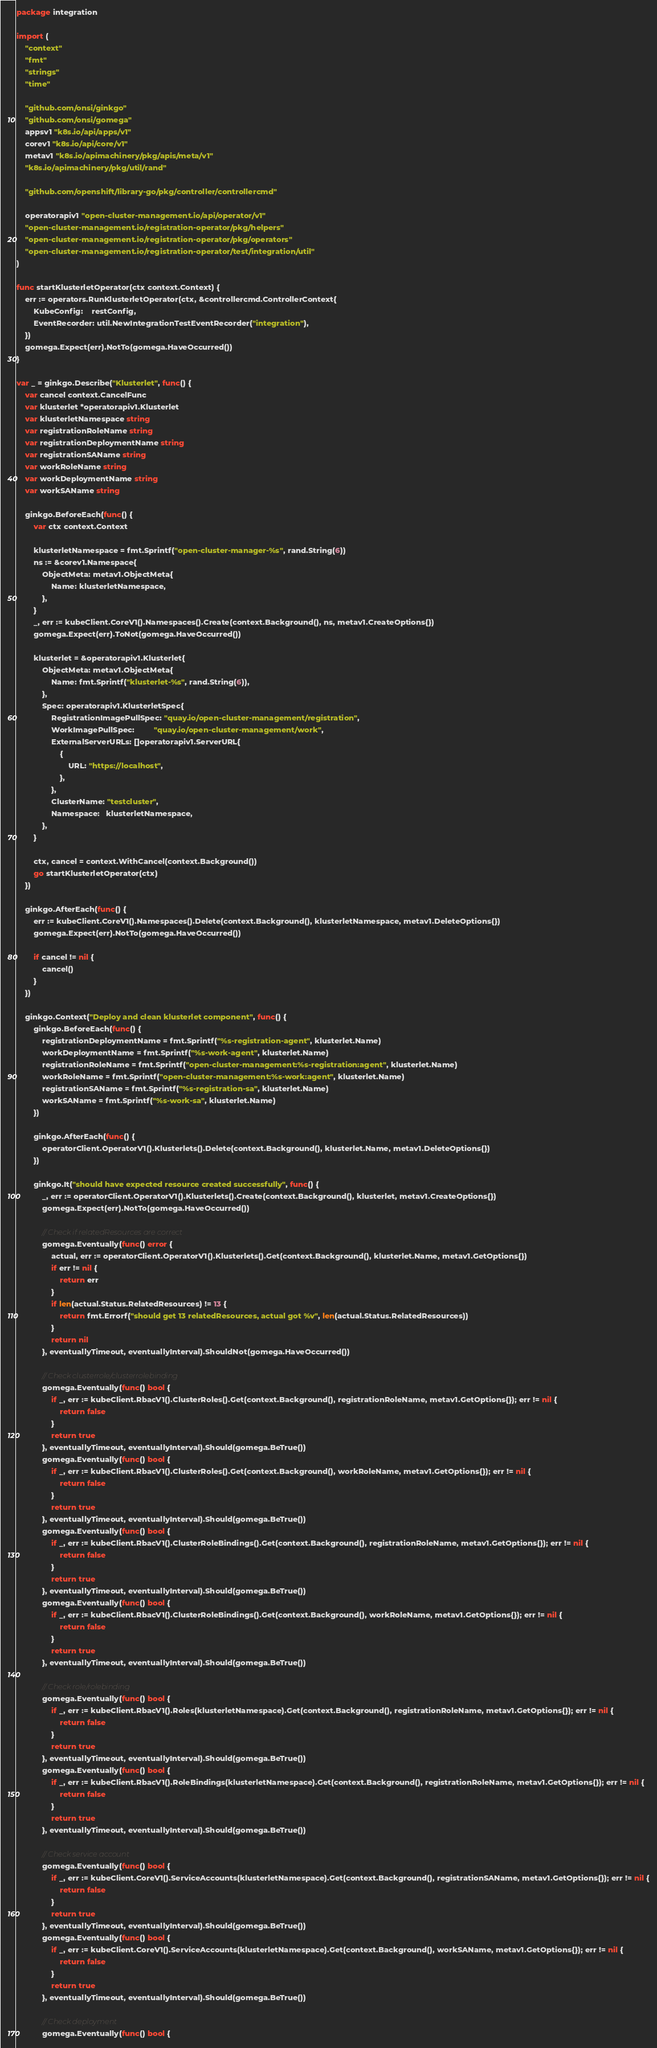Convert code to text. <code><loc_0><loc_0><loc_500><loc_500><_Go_>package integration

import (
	"context"
	"fmt"
	"strings"
	"time"

	"github.com/onsi/ginkgo"
	"github.com/onsi/gomega"
	appsv1 "k8s.io/api/apps/v1"
	corev1 "k8s.io/api/core/v1"
	metav1 "k8s.io/apimachinery/pkg/apis/meta/v1"
	"k8s.io/apimachinery/pkg/util/rand"

	"github.com/openshift/library-go/pkg/controller/controllercmd"

	operatorapiv1 "open-cluster-management.io/api/operator/v1"
	"open-cluster-management.io/registration-operator/pkg/helpers"
	"open-cluster-management.io/registration-operator/pkg/operators"
	"open-cluster-management.io/registration-operator/test/integration/util"
)

func startKlusterletOperator(ctx context.Context) {
	err := operators.RunKlusterletOperator(ctx, &controllercmd.ControllerContext{
		KubeConfig:    restConfig,
		EventRecorder: util.NewIntegrationTestEventRecorder("integration"),
	})
	gomega.Expect(err).NotTo(gomega.HaveOccurred())
}

var _ = ginkgo.Describe("Klusterlet", func() {
	var cancel context.CancelFunc
	var klusterlet *operatorapiv1.Klusterlet
	var klusterletNamespace string
	var registrationRoleName string
	var registrationDeploymentName string
	var registrationSAName string
	var workRoleName string
	var workDeploymentName string
	var workSAName string

	ginkgo.BeforeEach(func() {
		var ctx context.Context

		klusterletNamespace = fmt.Sprintf("open-cluster-manager-%s", rand.String(6))
		ns := &corev1.Namespace{
			ObjectMeta: metav1.ObjectMeta{
				Name: klusterletNamespace,
			},
		}
		_, err := kubeClient.CoreV1().Namespaces().Create(context.Background(), ns, metav1.CreateOptions{})
		gomega.Expect(err).ToNot(gomega.HaveOccurred())

		klusterlet = &operatorapiv1.Klusterlet{
			ObjectMeta: metav1.ObjectMeta{
				Name: fmt.Sprintf("klusterlet-%s", rand.String(6)),
			},
			Spec: operatorapiv1.KlusterletSpec{
				RegistrationImagePullSpec: "quay.io/open-cluster-management/registration",
				WorkImagePullSpec:         "quay.io/open-cluster-management/work",
				ExternalServerURLs: []operatorapiv1.ServerURL{
					{
						URL: "https://localhost",
					},
				},
				ClusterName: "testcluster",
				Namespace:   klusterletNamespace,
			},
		}

		ctx, cancel = context.WithCancel(context.Background())
		go startKlusterletOperator(ctx)
	})

	ginkgo.AfterEach(func() {
		err := kubeClient.CoreV1().Namespaces().Delete(context.Background(), klusterletNamespace, metav1.DeleteOptions{})
		gomega.Expect(err).NotTo(gomega.HaveOccurred())

		if cancel != nil {
			cancel()
		}
	})

	ginkgo.Context("Deploy and clean klusterlet component", func() {
		ginkgo.BeforeEach(func() {
			registrationDeploymentName = fmt.Sprintf("%s-registration-agent", klusterlet.Name)
			workDeploymentName = fmt.Sprintf("%s-work-agent", klusterlet.Name)
			registrationRoleName = fmt.Sprintf("open-cluster-management:%s-registration:agent", klusterlet.Name)
			workRoleName = fmt.Sprintf("open-cluster-management:%s-work:agent", klusterlet.Name)
			registrationSAName = fmt.Sprintf("%s-registration-sa", klusterlet.Name)
			workSAName = fmt.Sprintf("%s-work-sa", klusterlet.Name)
		})

		ginkgo.AfterEach(func() {
			operatorClient.OperatorV1().Klusterlets().Delete(context.Background(), klusterlet.Name, metav1.DeleteOptions{})
		})

		ginkgo.It("should have expected resource created successfully", func() {
			_, err := operatorClient.OperatorV1().Klusterlets().Create(context.Background(), klusterlet, metav1.CreateOptions{})
			gomega.Expect(err).NotTo(gomega.HaveOccurred())

			// Check if relatedResources are correct
			gomega.Eventually(func() error {
				actual, err := operatorClient.OperatorV1().Klusterlets().Get(context.Background(), klusterlet.Name, metav1.GetOptions{})
				if err != nil {
					return err
				}
				if len(actual.Status.RelatedResources) != 13 {
					return fmt.Errorf("should get 13 relatedResources, actual got %v", len(actual.Status.RelatedResources))
				}
				return nil
			}, eventuallyTimeout, eventuallyInterval).ShouldNot(gomega.HaveOccurred())

			// Check clusterrole/clusterrolebinding
			gomega.Eventually(func() bool {
				if _, err := kubeClient.RbacV1().ClusterRoles().Get(context.Background(), registrationRoleName, metav1.GetOptions{}); err != nil {
					return false
				}
				return true
			}, eventuallyTimeout, eventuallyInterval).Should(gomega.BeTrue())
			gomega.Eventually(func() bool {
				if _, err := kubeClient.RbacV1().ClusterRoles().Get(context.Background(), workRoleName, metav1.GetOptions{}); err != nil {
					return false
				}
				return true
			}, eventuallyTimeout, eventuallyInterval).Should(gomega.BeTrue())
			gomega.Eventually(func() bool {
				if _, err := kubeClient.RbacV1().ClusterRoleBindings().Get(context.Background(), registrationRoleName, metav1.GetOptions{}); err != nil {
					return false
				}
				return true
			}, eventuallyTimeout, eventuallyInterval).Should(gomega.BeTrue())
			gomega.Eventually(func() bool {
				if _, err := kubeClient.RbacV1().ClusterRoleBindings().Get(context.Background(), workRoleName, metav1.GetOptions{}); err != nil {
					return false
				}
				return true
			}, eventuallyTimeout, eventuallyInterval).Should(gomega.BeTrue())

			// Check role/rolebinding
			gomega.Eventually(func() bool {
				if _, err := kubeClient.RbacV1().Roles(klusterletNamespace).Get(context.Background(), registrationRoleName, metav1.GetOptions{}); err != nil {
					return false
				}
				return true
			}, eventuallyTimeout, eventuallyInterval).Should(gomega.BeTrue())
			gomega.Eventually(func() bool {
				if _, err := kubeClient.RbacV1().RoleBindings(klusterletNamespace).Get(context.Background(), registrationRoleName, metav1.GetOptions{}); err != nil {
					return false
				}
				return true
			}, eventuallyTimeout, eventuallyInterval).Should(gomega.BeTrue())

			// Check service account
			gomega.Eventually(func() bool {
				if _, err := kubeClient.CoreV1().ServiceAccounts(klusterletNamespace).Get(context.Background(), registrationSAName, metav1.GetOptions{}); err != nil {
					return false
				}
				return true
			}, eventuallyTimeout, eventuallyInterval).Should(gomega.BeTrue())
			gomega.Eventually(func() bool {
				if _, err := kubeClient.CoreV1().ServiceAccounts(klusterletNamespace).Get(context.Background(), workSAName, metav1.GetOptions{}); err != nil {
					return false
				}
				return true
			}, eventuallyTimeout, eventuallyInterval).Should(gomega.BeTrue())

			// Check deployment
			gomega.Eventually(func() bool {</code> 